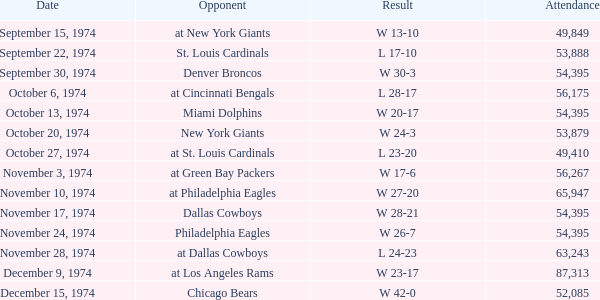What was the result of the game where 63,243 people attended after week 9? W 23-17. 